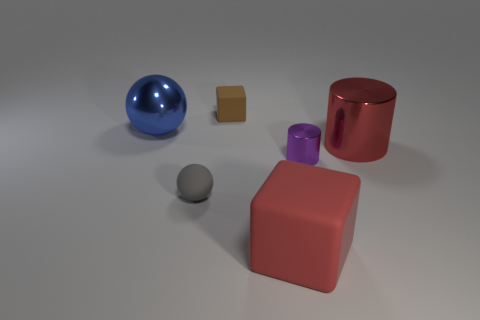Add 1 gray rubber objects. How many objects exist? 7 Subtract all purple cylinders. How many cylinders are left? 1 Subtract all cubes. How many objects are left? 4 Add 2 gray matte things. How many gray matte things are left? 3 Add 1 large red rubber things. How many large red rubber things exist? 2 Subtract 0 yellow spheres. How many objects are left? 6 Subtract all cyan cubes. Subtract all blue balls. How many cubes are left? 2 Subtract all red objects. Subtract all big objects. How many objects are left? 1 